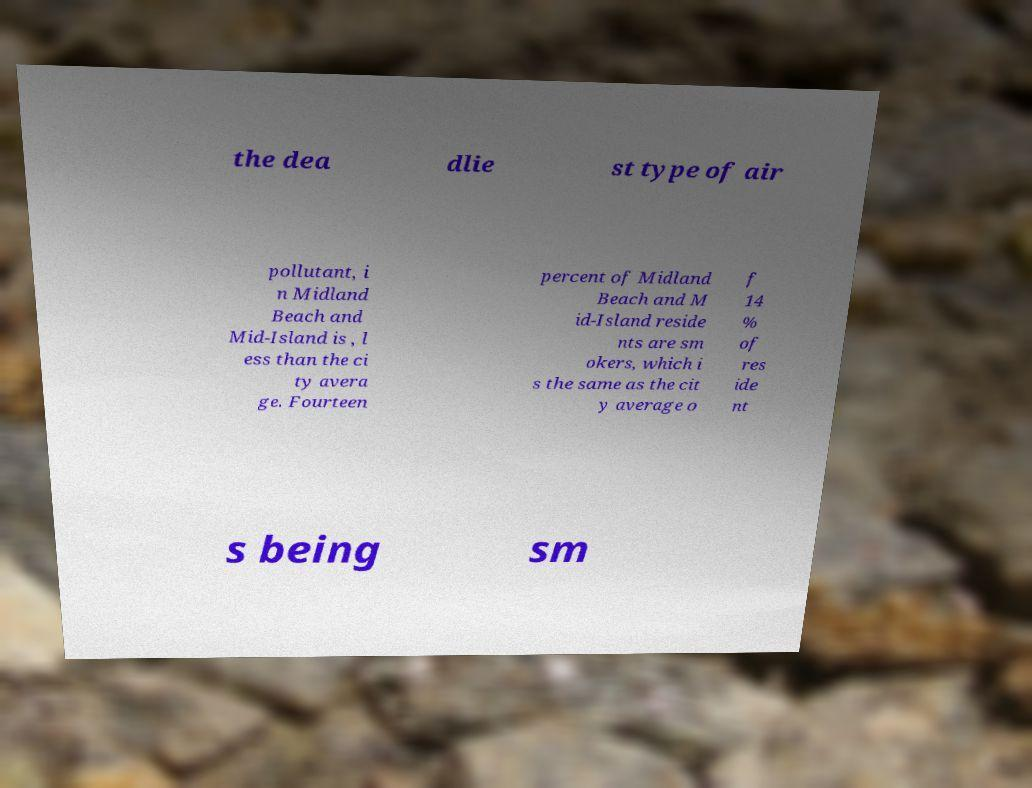Can you read and provide the text displayed in the image?This photo seems to have some interesting text. Can you extract and type it out for me? the dea dlie st type of air pollutant, i n Midland Beach and Mid-Island is , l ess than the ci ty avera ge. Fourteen percent of Midland Beach and M id-Island reside nts are sm okers, which i s the same as the cit y average o f 14 % of res ide nt s being sm 